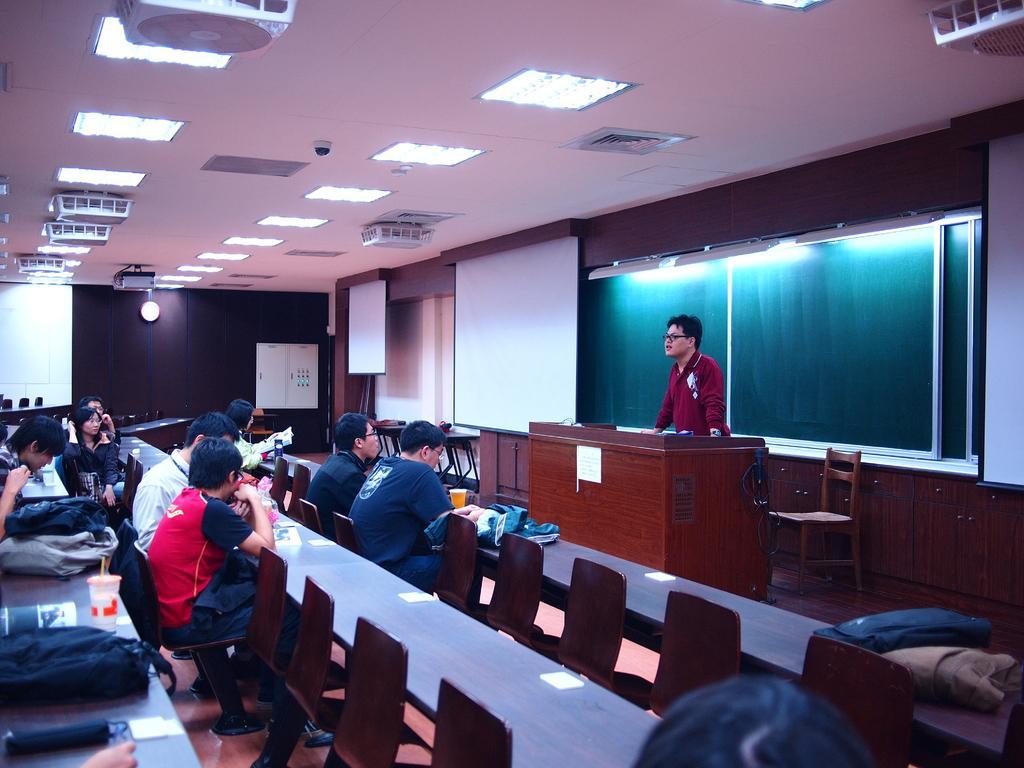Please provide a concise description of this image. This picture shows a group of people seated on the chairs and a man standing and speaking and we see a projector screen and few roof lights on the top 